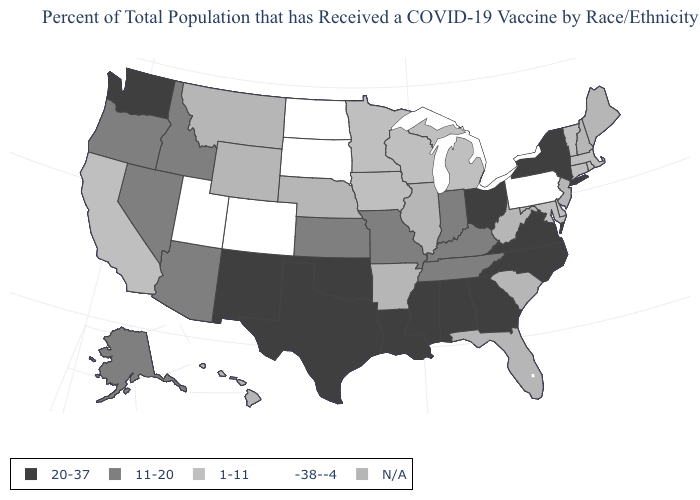What is the value of Ohio?
Quick response, please. 20-37. Does the first symbol in the legend represent the smallest category?
Be succinct. No. Does New Mexico have the lowest value in the USA?
Be succinct. No. What is the value of Missouri?
Keep it brief. 11-20. Does the first symbol in the legend represent the smallest category?
Short answer required. No. Name the states that have a value in the range -38--4?
Keep it brief. Colorado, North Dakota, Pennsylvania, South Dakota, Utah. Which states hav the highest value in the Northeast?
Short answer required. New York. Name the states that have a value in the range N/A?
Quick response, please. Arkansas, Florida, Hawaii, Illinois, Maine, Montana, Nebraska, New Hampshire, New Jersey, South Carolina, West Virginia, Wyoming. Does North Carolina have the highest value in the South?
Give a very brief answer. Yes. Name the states that have a value in the range -38--4?
Keep it brief. Colorado, North Dakota, Pennsylvania, South Dakota, Utah. Among the states that border Georgia , which have the highest value?
Answer briefly. Alabama, North Carolina. What is the lowest value in the USA?
Keep it brief. -38--4. 